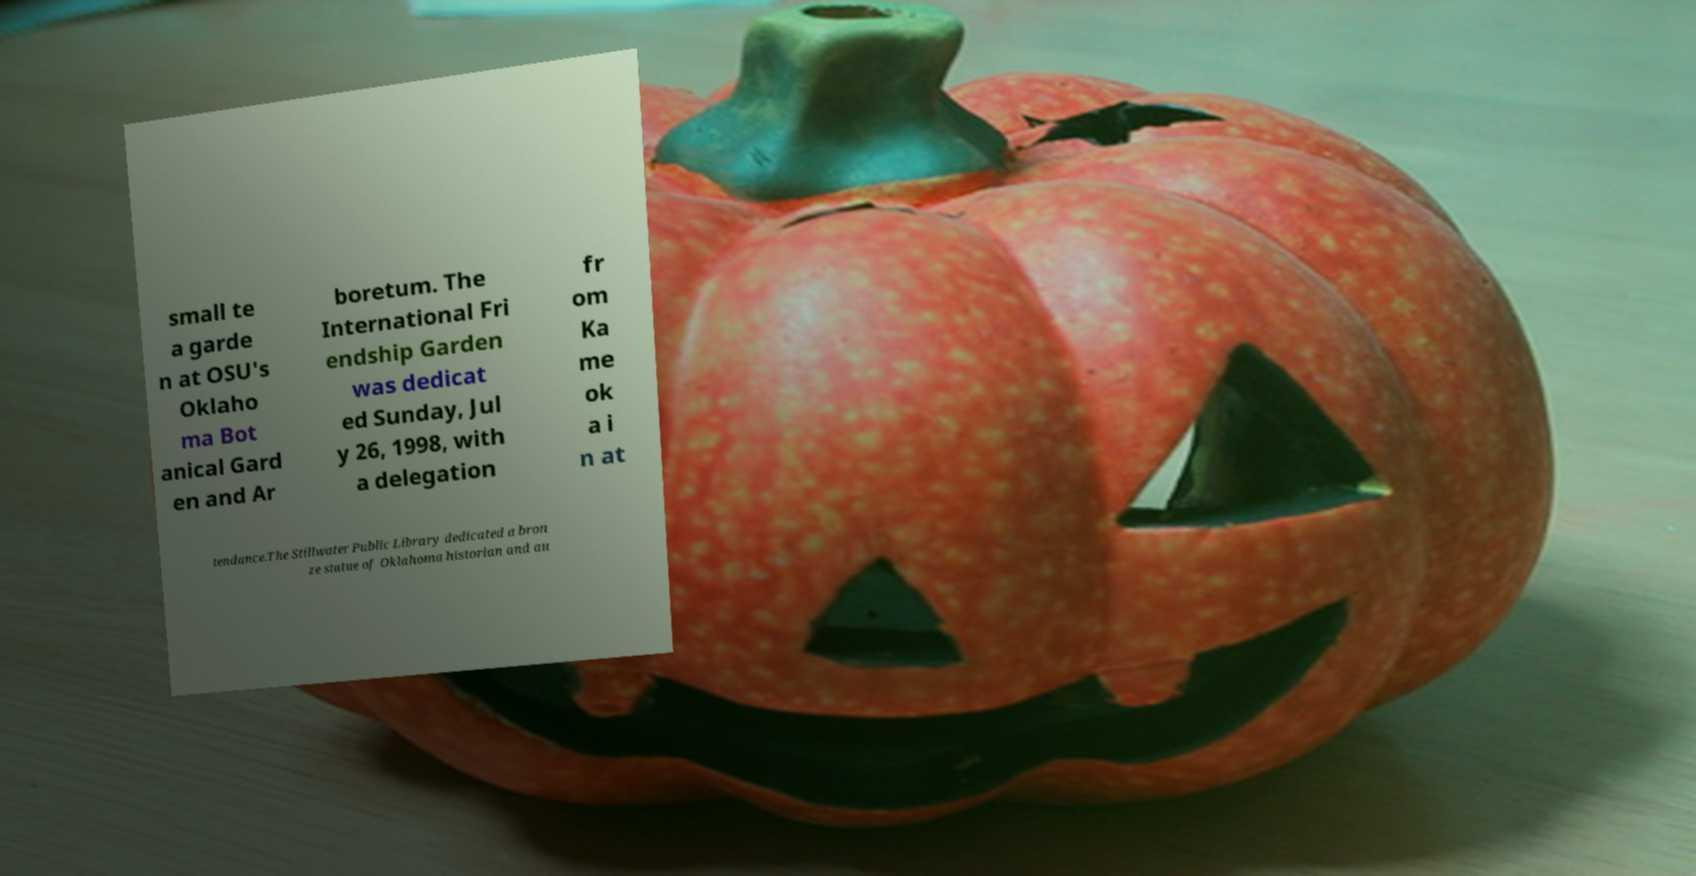Could you extract and type out the text from this image? small te a garde n at OSU's Oklaho ma Bot anical Gard en and Ar boretum. The International Fri endship Garden was dedicat ed Sunday, Jul y 26, 1998, with a delegation fr om Ka me ok a i n at tendance.The Stillwater Public Library dedicated a bron ze statue of Oklahoma historian and au 